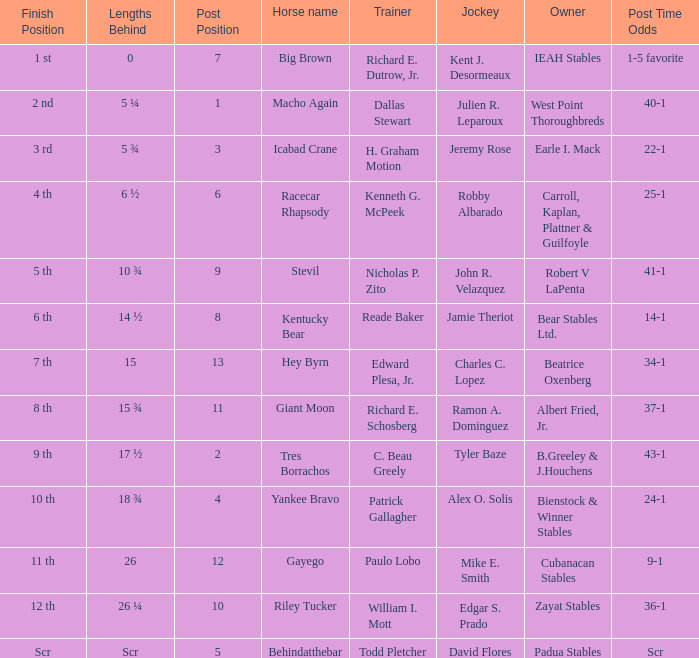What is the measurement behind jeremy rose? 5 ¾. 